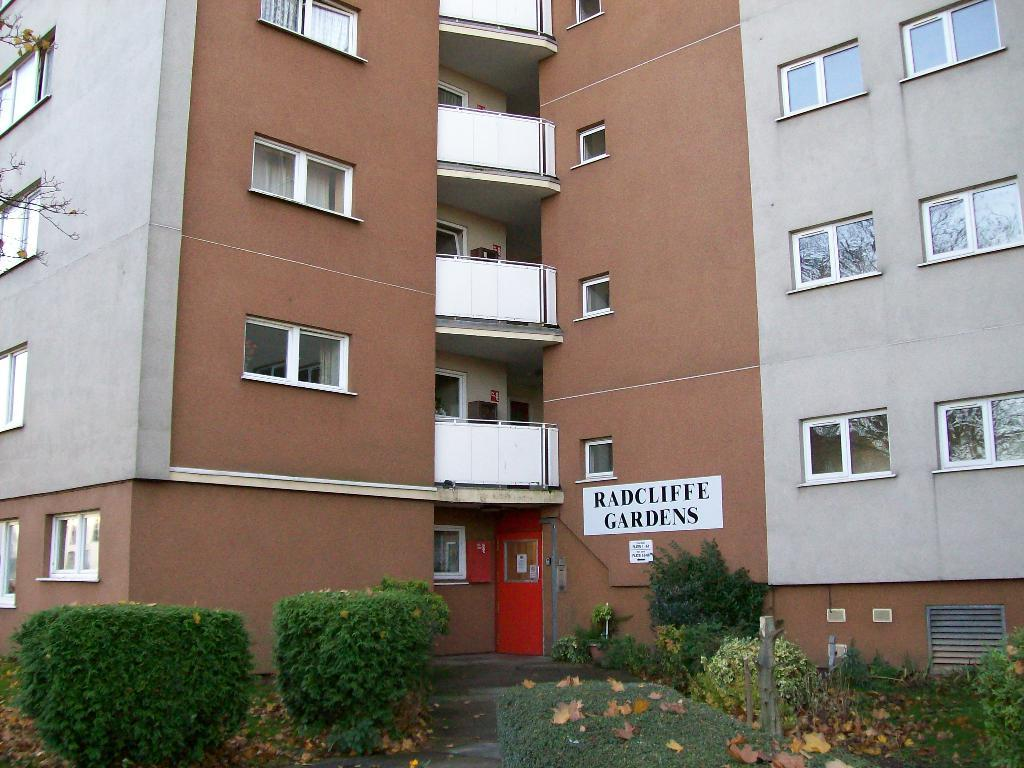What type of living organisms can be seen in the image? Plants can be seen in the image. What can be seen in the background of the image? There is a building with windows in the background of the image. What is written on a wall in the image? There is text written on a wall in the image. What type of wine is being served on the tray in the image? There is no tray or wine present in the image. 